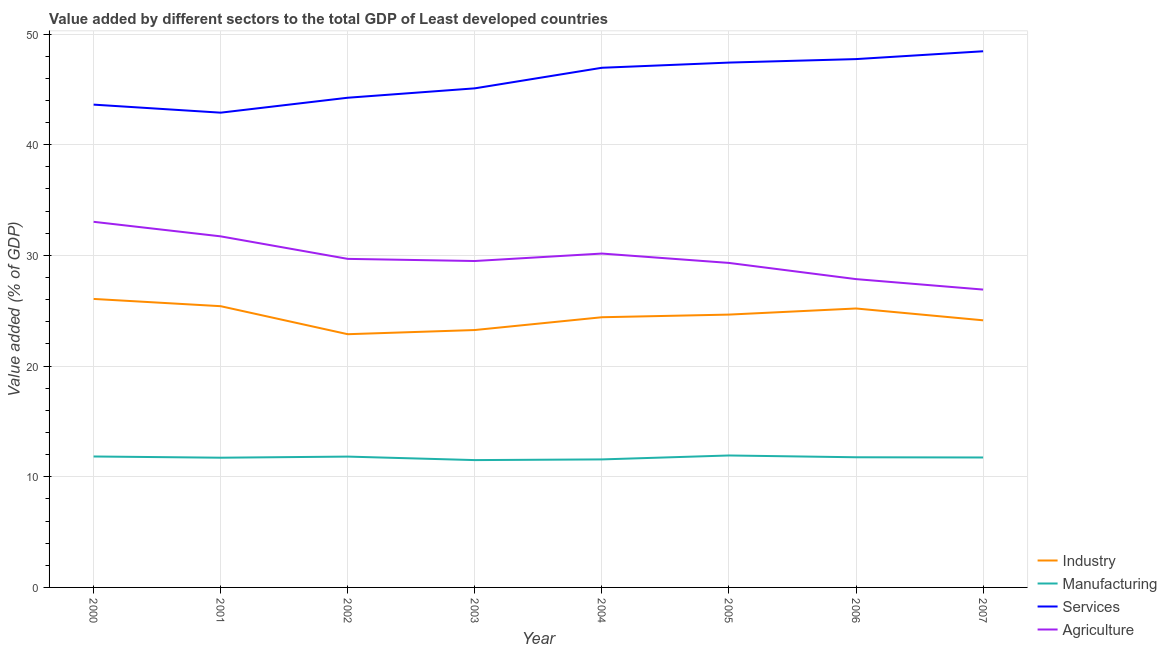Does the line corresponding to value added by services sector intersect with the line corresponding to value added by manufacturing sector?
Offer a very short reply. No. Is the number of lines equal to the number of legend labels?
Offer a very short reply. Yes. What is the value added by services sector in 2001?
Keep it short and to the point. 42.9. Across all years, what is the maximum value added by agricultural sector?
Your answer should be very brief. 33.04. Across all years, what is the minimum value added by services sector?
Offer a terse response. 42.9. In which year was the value added by manufacturing sector maximum?
Offer a very short reply. 2005. What is the total value added by services sector in the graph?
Ensure brevity in your answer.  366.42. What is the difference between the value added by industrial sector in 2001 and that in 2003?
Ensure brevity in your answer.  2.15. What is the difference between the value added by services sector in 2000 and the value added by agricultural sector in 2003?
Keep it short and to the point. 14.13. What is the average value added by services sector per year?
Offer a terse response. 45.8. In the year 2000, what is the difference between the value added by industrial sector and value added by agricultural sector?
Give a very brief answer. -6.97. In how many years, is the value added by agricultural sector greater than 42 %?
Provide a succinct answer. 0. What is the ratio of the value added by industrial sector in 2000 to that in 2006?
Give a very brief answer. 1.03. Is the value added by services sector in 2000 less than that in 2001?
Offer a terse response. No. What is the difference between the highest and the second highest value added by agricultural sector?
Ensure brevity in your answer.  1.31. What is the difference between the highest and the lowest value added by services sector?
Give a very brief answer. 5.55. In how many years, is the value added by services sector greater than the average value added by services sector taken over all years?
Your answer should be compact. 4. Is it the case that in every year, the sum of the value added by manufacturing sector and value added by agricultural sector is greater than the sum of value added by industrial sector and value added by services sector?
Make the answer very short. No. Does the value added by services sector monotonically increase over the years?
Give a very brief answer. No. Does the graph contain grids?
Offer a terse response. Yes. Where does the legend appear in the graph?
Give a very brief answer. Bottom right. What is the title of the graph?
Ensure brevity in your answer.  Value added by different sectors to the total GDP of Least developed countries. Does "CO2 damage" appear as one of the legend labels in the graph?
Keep it short and to the point. No. What is the label or title of the Y-axis?
Your answer should be compact. Value added (% of GDP). What is the Value added (% of GDP) in Industry in 2000?
Give a very brief answer. 26.07. What is the Value added (% of GDP) in Manufacturing in 2000?
Keep it short and to the point. 11.83. What is the Value added (% of GDP) in Services in 2000?
Provide a short and direct response. 43.62. What is the Value added (% of GDP) of Agriculture in 2000?
Your answer should be very brief. 33.04. What is the Value added (% of GDP) in Industry in 2001?
Offer a very short reply. 25.41. What is the Value added (% of GDP) of Manufacturing in 2001?
Offer a very short reply. 11.72. What is the Value added (% of GDP) in Services in 2001?
Offer a very short reply. 42.9. What is the Value added (% of GDP) in Agriculture in 2001?
Provide a short and direct response. 31.72. What is the Value added (% of GDP) in Industry in 2002?
Your answer should be compact. 22.88. What is the Value added (% of GDP) of Manufacturing in 2002?
Offer a very short reply. 11.82. What is the Value added (% of GDP) of Services in 2002?
Provide a short and direct response. 44.25. What is the Value added (% of GDP) of Agriculture in 2002?
Keep it short and to the point. 29.69. What is the Value added (% of GDP) in Industry in 2003?
Keep it short and to the point. 23.26. What is the Value added (% of GDP) of Manufacturing in 2003?
Give a very brief answer. 11.51. What is the Value added (% of GDP) in Services in 2003?
Your answer should be compact. 45.1. What is the Value added (% of GDP) of Agriculture in 2003?
Keep it short and to the point. 29.49. What is the Value added (% of GDP) of Industry in 2004?
Provide a short and direct response. 24.41. What is the Value added (% of GDP) in Manufacturing in 2004?
Provide a succinct answer. 11.57. What is the Value added (% of GDP) of Services in 2004?
Give a very brief answer. 46.95. What is the Value added (% of GDP) in Agriculture in 2004?
Your answer should be very brief. 30.17. What is the Value added (% of GDP) of Industry in 2005?
Make the answer very short. 24.65. What is the Value added (% of GDP) in Manufacturing in 2005?
Ensure brevity in your answer.  11.92. What is the Value added (% of GDP) of Services in 2005?
Your response must be concise. 47.42. What is the Value added (% of GDP) of Agriculture in 2005?
Provide a succinct answer. 29.32. What is the Value added (% of GDP) of Industry in 2006?
Offer a very short reply. 25.2. What is the Value added (% of GDP) of Manufacturing in 2006?
Your answer should be very brief. 11.76. What is the Value added (% of GDP) of Services in 2006?
Make the answer very short. 47.74. What is the Value added (% of GDP) of Agriculture in 2006?
Keep it short and to the point. 27.86. What is the Value added (% of GDP) in Industry in 2007?
Ensure brevity in your answer.  24.14. What is the Value added (% of GDP) in Manufacturing in 2007?
Keep it short and to the point. 11.74. What is the Value added (% of GDP) of Services in 2007?
Make the answer very short. 48.44. What is the Value added (% of GDP) in Agriculture in 2007?
Give a very brief answer. 26.91. Across all years, what is the maximum Value added (% of GDP) in Industry?
Ensure brevity in your answer.  26.07. Across all years, what is the maximum Value added (% of GDP) in Manufacturing?
Provide a short and direct response. 11.92. Across all years, what is the maximum Value added (% of GDP) of Services?
Offer a terse response. 48.44. Across all years, what is the maximum Value added (% of GDP) in Agriculture?
Provide a short and direct response. 33.04. Across all years, what is the minimum Value added (% of GDP) in Industry?
Offer a very short reply. 22.88. Across all years, what is the minimum Value added (% of GDP) of Manufacturing?
Keep it short and to the point. 11.51. Across all years, what is the minimum Value added (% of GDP) in Services?
Your answer should be very brief. 42.9. Across all years, what is the minimum Value added (% of GDP) of Agriculture?
Provide a short and direct response. 26.91. What is the total Value added (% of GDP) in Industry in the graph?
Your answer should be compact. 196.02. What is the total Value added (% of GDP) in Manufacturing in the graph?
Your response must be concise. 93.87. What is the total Value added (% of GDP) of Services in the graph?
Your answer should be very brief. 366.42. What is the total Value added (% of GDP) in Agriculture in the graph?
Your answer should be very brief. 238.19. What is the difference between the Value added (% of GDP) of Industry in 2000 and that in 2001?
Offer a very short reply. 0.66. What is the difference between the Value added (% of GDP) of Manufacturing in 2000 and that in 2001?
Your answer should be compact. 0.11. What is the difference between the Value added (% of GDP) of Services in 2000 and that in 2001?
Offer a terse response. 0.73. What is the difference between the Value added (% of GDP) of Agriculture in 2000 and that in 2001?
Offer a terse response. 1.31. What is the difference between the Value added (% of GDP) of Industry in 2000 and that in 2002?
Provide a succinct answer. 3.19. What is the difference between the Value added (% of GDP) of Manufacturing in 2000 and that in 2002?
Your answer should be very brief. 0.01. What is the difference between the Value added (% of GDP) of Services in 2000 and that in 2002?
Provide a short and direct response. -0.62. What is the difference between the Value added (% of GDP) of Agriculture in 2000 and that in 2002?
Your response must be concise. 3.35. What is the difference between the Value added (% of GDP) of Industry in 2000 and that in 2003?
Offer a terse response. 2.81. What is the difference between the Value added (% of GDP) of Manufacturing in 2000 and that in 2003?
Your answer should be very brief. 0.33. What is the difference between the Value added (% of GDP) of Services in 2000 and that in 2003?
Provide a succinct answer. -1.47. What is the difference between the Value added (% of GDP) in Agriculture in 2000 and that in 2003?
Provide a short and direct response. 3.54. What is the difference between the Value added (% of GDP) of Industry in 2000 and that in 2004?
Offer a terse response. 1.65. What is the difference between the Value added (% of GDP) of Manufacturing in 2000 and that in 2004?
Provide a succinct answer. 0.26. What is the difference between the Value added (% of GDP) in Services in 2000 and that in 2004?
Ensure brevity in your answer.  -3.33. What is the difference between the Value added (% of GDP) in Agriculture in 2000 and that in 2004?
Your response must be concise. 2.87. What is the difference between the Value added (% of GDP) in Industry in 2000 and that in 2005?
Give a very brief answer. 1.42. What is the difference between the Value added (% of GDP) of Manufacturing in 2000 and that in 2005?
Keep it short and to the point. -0.09. What is the difference between the Value added (% of GDP) of Services in 2000 and that in 2005?
Make the answer very short. -3.8. What is the difference between the Value added (% of GDP) in Agriculture in 2000 and that in 2005?
Ensure brevity in your answer.  3.71. What is the difference between the Value added (% of GDP) of Industry in 2000 and that in 2006?
Your answer should be compact. 0.86. What is the difference between the Value added (% of GDP) in Manufacturing in 2000 and that in 2006?
Provide a short and direct response. 0.07. What is the difference between the Value added (% of GDP) of Services in 2000 and that in 2006?
Provide a short and direct response. -4.11. What is the difference between the Value added (% of GDP) of Agriculture in 2000 and that in 2006?
Your answer should be compact. 5.18. What is the difference between the Value added (% of GDP) in Industry in 2000 and that in 2007?
Provide a succinct answer. 1.93. What is the difference between the Value added (% of GDP) in Manufacturing in 2000 and that in 2007?
Offer a terse response. 0.09. What is the difference between the Value added (% of GDP) in Services in 2000 and that in 2007?
Offer a terse response. -4.82. What is the difference between the Value added (% of GDP) of Agriculture in 2000 and that in 2007?
Give a very brief answer. 6.12. What is the difference between the Value added (% of GDP) in Industry in 2001 and that in 2002?
Offer a very short reply. 2.53. What is the difference between the Value added (% of GDP) in Manufacturing in 2001 and that in 2002?
Give a very brief answer. -0.1. What is the difference between the Value added (% of GDP) in Services in 2001 and that in 2002?
Ensure brevity in your answer.  -1.35. What is the difference between the Value added (% of GDP) in Agriculture in 2001 and that in 2002?
Provide a succinct answer. 2.03. What is the difference between the Value added (% of GDP) in Industry in 2001 and that in 2003?
Your answer should be very brief. 2.15. What is the difference between the Value added (% of GDP) of Manufacturing in 2001 and that in 2003?
Provide a succinct answer. 0.22. What is the difference between the Value added (% of GDP) in Services in 2001 and that in 2003?
Give a very brief answer. -2.2. What is the difference between the Value added (% of GDP) in Agriculture in 2001 and that in 2003?
Your answer should be very brief. 2.23. What is the difference between the Value added (% of GDP) of Industry in 2001 and that in 2004?
Your response must be concise. 1. What is the difference between the Value added (% of GDP) of Manufacturing in 2001 and that in 2004?
Offer a terse response. 0.15. What is the difference between the Value added (% of GDP) of Services in 2001 and that in 2004?
Make the answer very short. -4.06. What is the difference between the Value added (% of GDP) of Agriculture in 2001 and that in 2004?
Provide a succinct answer. 1.55. What is the difference between the Value added (% of GDP) in Industry in 2001 and that in 2005?
Provide a short and direct response. 0.76. What is the difference between the Value added (% of GDP) of Manufacturing in 2001 and that in 2005?
Keep it short and to the point. -0.2. What is the difference between the Value added (% of GDP) in Services in 2001 and that in 2005?
Give a very brief answer. -4.53. What is the difference between the Value added (% of GDP) in Agriculture in 2001 and that in 2005?
Your answer should be very brief. 2.4. What is the difference between the Value added (% of GDP) in Industry in 2001 and that in 2006?
Offer a very short reply. 0.21. What is the difference between the Value added (% of GDP) in Manufacturing in 2001 and that in 2006?
Provide a short and direct response. -0.04. What is the difference between the Value added (% of GDP) of Services in 2001 and that in 2006?
Provide a short and direct response. -4.84. What is the difference between the Value added (% of GDP) of Agriculture in 2001 and that in 2006?
Provide a succinct answer. 3.86. What is the difference between the Value added (% of GDP) in Industry in 2001 and that in 2007?
Your answer should be compact. 1.28. What is the difference between the Value added (% of GDP) in Manufacturing in 2001 and that in 2007?
Your answer should be compact. -0.02. What is the difference between the Value added (% of GDP) in Services in 2001 and that in 2007?
Offer a terse response. -5.55. What is the difference between the Value added (% of GDP) of Agriculture in 2001 and that in 2007?
Your response must be concise. 4.81. What is the difference between the Value added (% of GDP) of Industry in 2002 and that in 2003?
Give a very brief answer. -0.38. What is the difference between the Value added (% of GDP) of Manufacturing in 2002 and that in 2003?
Ensure brevity in your answer.  0.32. What is the difference between the Value added (% of GDP) of Services in 2002 and that in 2003?
Your answer should be compact. -0.85. What is the difference between the Value added (% of GDP) in Agriculture in 2002 and that in 2003?
Ensure brevity in your answer.  0.19. What is the difference between the Value added (% of GDP) in Industry in 2002 and that in 2004?
Offer a very short reply. -1.53. What is the difference between the Value added (% of GDP) of Manufacturing in 2002 and that in 2004?
Keep it short and to the point. 0.25. What is the difference between the Value added (% of GDP) in Services in 2002 and that in 2004?
Make the answer very short. -2.71. What is the difference between the Value added (% of GDP) of Agriculture in 2002 and that in 2004?
Your answer should be very brief. -0.48. What is the difference between the Value added (% of GDP) of Industry in 2002 and that in 2005?
Ensure brevity in your answer.  -1.77. What is the difference between the Value added (% of GDP) of Manufacturing in 2002 and that in 2005?
Your answer should be compact. -0.1. What is the difference between the Value added (% of GDP) in Services in 2002 and that in 2005?
Give a very brief answer. -3.18. What is the difference between the Value added (% of GDP) of Agriculture in 2002 and that in 2005?
Make the answer very short. 0.37. What is the difference between the Value added (% of GDP) in Industry in 2002 and that in 2006?
Your response must be concise. -2.32. What is the difference between the Value added (% of GDP) in Manufacturing in 2002 and that in 2006?
Your answer should be compact. 0.06. What is the difference between the Value added (% of GDP) in Services in 2002 and that in 2006?
Keep it short and to the point. -3.49. What is the difference between the Value added (% of GDP) in Agriculture in 2002 and that in 2006?
Provide a succinct answer. 1.83. What is the difference between the Value added (% of GDP) of Industry in 2002 and that in 2007?
Make the answer very short. -1.26. What is the difference between the Value added (% of GDP) of Manufacturing in 2002 and that in 2007?
Offer a very short reply. 0.08. What is the difference between the Value added (% of GDP) in Services in 2002 and that in 2007?
Offer a very short reply. -4.2. What is the difference between the Value added (% of GDP) in Agriculture in 2002 and that in 2007?
Offer a very short reply. 2.77. What is the difference between the Value added (% of GDP) of Industry in 2003 and that in 2004?
Offer a very short reply. -1.16. What is the difference between the Value added (% of GDP) of Manufacturing in 2003 and that in 2004?
Your response must be concise. -0.06. What is the difference between the Value added (% of GDP) in Services in 2003 and that in 2004?
Your response must be concise. -1.86. What is the difference between the Value added (% of GDP) in Agriculture in 2003 and that in 2004?
Offer a very short reply. -0.67. What is the difference between the Value added (% of GDP) of Industry in 2003 and that in 2005?
Provide a short and direct response. -1.39. What is the difference between the Value added (% of GDP) in Manufacturing in 2003 and that in 2005?
Provide a short and direct response. -0.42. What is the difference between the Value added (% of GDP) of Services in 2003 and that in 2005?
Give a very brief answer. -2.33. What is the difference between the Value added (% of GDP) of Agriculture in 2003 and that in 2005?
Provide a succinct answer. 0.17. What is the difference between the Value added (% of GDP) of Industry in 2003 and that in 2006?
Give a very brief answer. -1.95. What is the difference between the Value added (% of GDP) of Manufacturing in 2003 and that in 2006?
Offer a terse response. -0.26. What is the difference between the Value added (% of GDP) in Services in 2003 and that in 2006?
Your answer should be compact. -2.64. What is the difference between the Value added (% of GDP) in Agriculture in 2003 and that in 2006?
Give a very brief answer. 1.64. What is the difference between the Value added (% of GDP) in Industry in 2003 and that in 2007?
Your answer should be compact. -0.88. What is the difference between the Value added (% of GDP) in Manufacturing in 2003 and that in 2007?
Your answer should be compact. -0.24. What is the difference between the Value added (% of GDP) of Services in 2003 and that in 2007?
Make the answer very short. -3.35. What is the difference between the Value added (% of GDP) in Agriculture in 2003 and that in 2007?
Provide a succinct answer. 2.58. What is the difference between the Value added (% of GDP) of Industry in 2004 and that in 2005?
Provide a succinct answer. -0.24. What is the difference between the Value added (% of GDP) of Manufacturing in 2004 and that in 2005?
Your answer should be very brief. -0.36. What is the difference between the Value added (% of GDP) in Services in 2004 and that in 2005?
Your answer should be very brief. -0.47. What is the difference between the Value added (% of GDP) in Agriculture in 2004 and that in 2005?
Give a very brief answer. 0.85. What is the difference between the Value added (% of GDP) in Industry in 2004 and that in 2006?
Your response must be concise. -0.79. What is the difference between the Value added (% of GDP) of Manufacturing in 2004 and that in 2006?
Keep it short and to the point. -0.19. What is the difference between the Value added (% of GDP) in Services in 2004 and that in 2006?
Offer a terse response. -0.78. What is the difference between the Value added (% of GDP) of Agriculture in 2004 and that in 2006?
Your answer should be very brief. 2.31. What is the difference between the Value added (% of GDP) in Industry in 2004 and that in 2007?
Ensure brevity in your answer.  0.28. What is the difference between the Value added (% of GDP) in Manufacturing in 2004 and that in 2007?
Your answer should be very brief. -0.17. What is the difference between the Value added (% of GDP) of Services in 2004 and that in 2007?
Provide a succinct answer. -1.49. What is the difference between the Value added (% of GDP) in Agriculture in 2004 and that in 2007?
Offer a very short reply. 3.25. What is the difference between the Value added (% of GDP) of Industry in 2005 and that in 2006?
Offer a terse response. -0.55. What is the difference between the Value added (% of GDP) in Manufacturing in 2005 and that in 2006?
Your response must be concise. 0.16. What is the difference between the Value added (% of GDP) of Services in 2005 and that in 2006?
Your answer should be very brief. -0.32. What is the difference between the Value added (% of GDP) in Agriculture in 2005 and that in 2006?
Your answer should be compact. 1.46. What is the difference between the Value added (% of GDP) in Industry in 2005 and that in 2007?
Offer a very short reply. 0.52. What is the difference between the Value added (% of GDP) of Manufacturing in 2005 and that in 2007?
Your answer should be compact. 0.18. What is the difference between the Value added (% of GDP) of Services in 2005 and that in 2007?
Make the answer very short. -1.02. What is the difference between the Value added (% of GDP) in Agriculture in 2005 and that in 2007?
Ensure brevity in your answer.  2.41. What is the difference between the Value added (% of GDP) of Industry in 2006 and that in 2007?
Make the answer very short. 1.07. What is the difference between the Value added (% of GDP) of Manufacturing in 2006 and that in 2007?
Give a very brief answer. 0.02. What is the difference between the Value added (% of GDP) of Services in 2006 and that in 2007?
Ensure brevity in your answer.  -0.71. What is the difference between the Value added (% of GDP) of Agriculture in 2006 and that in 2007?
Offer a very short reply. 0.94. What is the difference between the Value added (% of GDP) of Industry in 2000 and the Value added (% of GDP) of Manufacturing in 2001?
Provide a short and direct response. 14.35. What is the difference between the Value added (% of GDP) in Industry in 2000 and the Value added (% of GDP) in Services in 2001?
Your response must be concise. -16.83. What is the difference between the Value added (% of GDP) in Industry in 2000 and the Value added (% of GDP) in Agriculture in 2001?
Ensure brevity in your answer.  -5.65. What is the difference between the Value added (% of GDP) in Manufacturing in 2000 and the Value added (% of GDP) in Services in 2001?
Give a very brief answer. -31.07. What is the difference between the Value added (% of GDP) of Manufacturing in 2000 and the Value added (% of GDP) of Agriculture in 2001?
Make the answer very short. -19.89. What is the difference between the Value added (% of GDP) of Services in 2000 and the Value added (% of GDP) of Agriculture in 2001?
Keep it short and to the point. 11.9. What is the difference between the Value added (% of GDP) of Industry in 2000 and the Value added (% of GDP) of Manufacturing in 2002?
Provide a succinct answer. 14.25. What is the difference between the Value added (% of GDP) in Industry in 2000 and the Value added (% of GDP) in Services in 2002?
Ensure brevity in your answer.  -18.18. What is the difference between the Value added (% of GDP) in Industry in 2000 and the Value added (% of GDP) in Agriculture in 2002?
Keep it short and to the point. -3.62. What is the difference between the Value added (% of GDP) of Manufacturing in 2000 and the Value added (% of GDP) of Services in 2002?
Your answer should be compact. -32.41. What is the difference between the Value added (% of GDP) in Manufacturing in 2000 and the Value added (% of GDP) in Agriculture in 2002?
Give a very brief answer. -17.86. What is the difference between the Value added (% of GDP) in Services in 2000 and the Value added (% of GDP) in Agriculture in 2002?
Your response must be concise. 13.94. What is the difference between the Value added (% of GDP) in Industry in 2000 and the Value added (% of GDP) in Manufacturing in 2003?
Offer a very short reply. 14.56. What is the difference between the Value added (% of GDP) of Industry in 2000 and the Value added (% of GDP) of Services in 2003?
Your answer should be very brief. -19.03. What is the difference between the Value added (% of GDP) of Industry in 2000 and the Value added (% of GDP) of Agriculture in 2003?
Offer a terse response. -3.43. What is the difference between the Value added (% of GDP) of Manufacturing in 2000 and the Value added (% of GDP) of Services in 2003?
Offer a very short reply. -33.26. What is the difference between the Value added (% of GDP) of Manufacturing in 2000 and the Value added (% of GDP) of Agriculture in 2003?
Your response must be concise. -17.66. What is the difference between the Value added (% of GDP) of Services in 2000 and the Value added (% of GDP) of Agriculture in 2003?
Your answer should be compact. 14.13. What is the difference between the Value added (% of GDP) in Industry in 2000 and the Value added (% of GDP) in Services in 2004?
Give a very brief answer. -20.89. What is the difference between the Value added (% of GDP) of Industry in 2000 and the Value added (% of GDP) of Agriculture in 2004?
Provide a short and direct response. -4.1. What is the difference between the Value added (% of GDP) in Manufacturing in 2000 and the Value added (% of GDP) in Services in 2004?
Your answer should be very brief. -35.12. What is the difference between the Value added (% of GDP) in Manufacturing in 2000 and the Value added (% of GDP) in Agriculture in 2004?
Ensure brevity in your answer.  -18.33. What is the difference between the Value added (% of GDP) in Services in 2000 and the Value added (% of GDP) in Agriculture in 2004?
Keep it short and to the point. 13.46. What is the difference between the Value added (% of GDP) in Industry in 2000 and the Value added (% of GDP) in Manufacturing in 2005?
Your response must be concise. 14.14. What is the difference between the Value added (% of GDP) in Industry in 2000 and the Value added (% of GDP) in Services in 2005?
Keep it short and to the point. -21.35. What is the difference between the Value added (% of GDP) of Industry in 2000 and the Value added (% of GDP) of Agriculture in 2005?
Offer a very short reply. -3.25. What is the difference between the Value added (% of GDP) of Manufacturing in 2000 and the Value added (% of GDP) of Services in 2005?
Offer a terse response. -35.59. What is the difference between the Value added (% of GDP) in Manufacturing in 2000 and the Value added (% of GDP) in Agriculture in 2005?
Offer a terse response. -17.49. What is the difference between the Value added (% of GDP) in Services in 2000 and the Value added (% of GDP) in Agriculture in 2005?
Give a very brief answer. 14.3. What is the difference between the Value added (% of GDP) of Industry in 2000 and the Value added (% of GDP) of Manufacturing in 2006?
Keep it short and to the point. 14.31. What is the difference between the Value added (% of GDP) in Industry in 2000 and the Value added (% of GDP) in Services in 2006?
Offer a very short reply. -21.67. What is the difference between the Value added (% of GDP) in Industry in 2000 and the Value added (% of GDP) in Agriculture in 2006?
Your answer should be very brief. -1.79. What is the difference between the Value added (% of GDP) of Manufacturing in 2000 and the Value added (% of GDP) of Services in 2006?
Your answer should be very brief. -35.91. What is the difference between the Value added (% of GDP) of Manufacturing in 2000 and the Value added (% of GDP) of Agriculture in 2006?
Offer a terse response. -16.03. What is the difference between the Value added (% of GDP) of Services in 2000 and the Value added (% of GDP) of Agriculture in 2006?
Keep it short and to the point. 15.77. What is the difference between the Value added (% of GDP) in Industry in 2000 and the Value added (% of GDP) in Manufacturing in 2007?
Provide a succinct answer. 14.33. What is the difference between the Value added (% of GDP) in Industry in 2000 and the Value added (% of GDP) in Services in 2007?
Provide a succinct answer. -22.38. What is the difference between the Value added (% of GDP) of Industry in 2000 and the Value added (% of GDP) of Agriculture in 2007?
Your answer should be very brief. -0.85. What is the difference between the Value added (% of GDP) of Manufacturing in 2000 and the Value added (% of GDP) of Services in 2007?
Give a very brief answer. -36.61. What is the difference between the Value added (% of GDP) of Manufacturing in 2000 and the Value added (% of GDP) of Agriculture in 2007?
Your answer should be very brief. -15.08. What is the difference between the Value added (% of GDP) of Services in 2000 and the Value added (% of GDP) of Agriculture in 2007?
Your answer should be compact. 16.71. What is the difference between the Value added (% of GDP) of Industry in 2001 and the Value added (% of GDP) of Manufacturing in 2002?
Your response must be concise. 13.59. What is the difference between the Value added (% of GDP) of Industry in 2001 and the Value added (% of GDP) of Services in 2002?
Provide a short and direct response. -18.84. What is the difference between the Value added (% of GDP) in Industry in 2001 and the Value added (% of GDP) in Agriculture in 2002?
Provide a short and direct response. -4.28. What is the difference between the Value added (% of GDP) in Manufacturing in 2001 and the Value added (% of GDP) in Services in 2002?
Provide a short and direct response. -32.53. What is the difference between the Value added (% of GDP) of Manufacturing in 2001 and the Value added (% of GDP) of Agriculture in 2002?
Provide a short and direct response. -17.97. What is the difference between the Value added (% of GDP) in Services in 2001 and the Value added (% of GDP) in Agriculture in 2002?
Ensure brevity in your answer.  13.21. What is the difference between the Value added (% of GDP) in Industry in 2001 and the Value added (% of GDP) in Manufacturing in 2003?
Provide a succinct answer. 13.91. What is the difference between the Value added (% of GDP) in Industry in 2001 and the Value added (% of GDP) in Services in 2003?
Offer a terse response. -19.68. What is the difference between the Value added (% of GDP) in Industry in 2001 and the Value added (% of GDP) in Agriculture in 2003?
Your response must be concise. -4.08. What is the difference between the Value added (% of GDP) of Manufacturing in 2001 and the Value added (% of GDP) of Services in 2003?
Provide a succinct answer. -33.37. What is the difference between the Value added (% of GDP) in Manufacturing in 2001 and the Value added (% of GDP) in Agriculture in 2003?
Keep it short and to the point. -17.77. What is the difference between the Value added (% of GDP) of Services in 2001 and the Value added (% of GDP) of Agriculture in 2003?
Offer a terse response. 13.4. What is the difference between the Value added (% of GDP) in Industry in 2001 and the Value added (% of GDP) in Manufacturing in 2004?
Offer a very short reply. 13.84. What is the difference between the Value added (% of GDP) in Industry in 2001 and the Value added (% of GDP) in Services in 2004?
Give a very brief answer. -21.54. What is the difference between the Value added (% of GDP) in Industry in 2001 and the Value added (% of GDP) in Agriculture in 2004?
Keep it short and to the point. -4.75. What is the difference between the Value added (% of GDP) of Manufacturing in 2001 and the Value added (% of GDP) of Services in 2004?
Keep it short and to the point. -35.23. What is the difference between the Value added (% of GDP) in Manufacturing in 2001 and the Value added (% of GDP) in Agriculture in 2004?
Your answer should be very brief. -18.45. What is the difference between the Value added (% of GDP) in Services in 2001 and the Value added (% of GDP) in Agriculture in 2004?
Provide a succinct answer. 12.73. What is the difference between the Value added (% of GDP) in Industry in 2001 and the Value added (% of GDP) in Manufacturing in 2005?
Provide a succinct answer. 13.49. What is the difference between the Value added (% of GDP) of Industry in 2001 and the Value added (% of GDP) of Services in 2005?
Make the answer very short. -22.01. What is the difference between the Value added (% of GDP) of Industry in 2001 and the Value added (% of GDP) of Agriculture in 2005?
Your answer should be very brief. -3.91. What is the difference between the Value added (% of GDP) of Manufacturing in 2001 and the Value added (% of GDP) of Services in 2005?
Offer a terse response. -35.7. What is the difference between the Value added (% of GDP) of Manufacturing in 2001 and the Value added (% of GDP) of Agriculture in 2005?
Provide a short and direct response. -17.6. What is the difference between the Value added (% of GDP) of Services in 2001 and the Value added (% of GDP) of Agriculture in 2005?
Your response must be concise. 13.58. What is the difference between the Value added (% of GDP) in Industry in 2001 and the Value added (% of GDP) in Manufacturing in 2006?
Ensure brevity in your answer.  13.65. What is the difference between the Value added (% of GDP) of Industry in 2001 and the Value added (% of GDP) of Services in 2006?
Provide a succinct answer. -22.33. What is the difference between the Value added (% of GDP) in Industry in 2001 and the Value added (% of GDP) in Agriculture in 2006?
Give a very brief answer. -2.45. What is the difference between the Value added (% of GDP) in Manufacturing in 2001 and the Value added (% of GDP) in Services in 2006?
Keep it short and to the point. -36.02. What is the difference between the Value added (% of GDP) in Manufacturing in 2001 and the Value added (% of GDP) in Agriculture in 2006?
Your answer should be very brief. -16.14. What is the difference between the Value added (% of GDP) of Services in 2001 and the Value added (% of GDP) of Agriculture in 2006?
Ensure brevity in your answer.  15.04. What is the difference between the Value added (% of GDP) of Industry in 2001 and the Value added (% of GDP) of Manufacturing in 2007?
Make the answer very short. 13.67. What is the difference between the Value added (% of GDP) of Industry in 2001 and the Value added (% of GDP) of Services in 2007?
Make the answer very short. -23.03. What is the difference between the Value added (% of GDP) of Industry in 2001 and the Value added (% of GDP) of Agriculture in 2007?
Provide a succinct answer. -1.5. What is the difference between the Value added (% of GDP) of Manufacturing in 2001 and the Value added (% of GDP) of Services in 2007?
Offer a very short reply. -36.72. What is the difference between the Value added (% of GDP) of Manufacturing in 2001 and the Value added (% of GDP) of Agriculture in 2007?
Offer a very short reply. -15.19. What is the difference between the Value added (% of GDP) of Services in 2001 and the Value added (% of GDP) of Agriculture in 2007?
Make the answer very short. 15.98. What is the difference between the Value added (% of GDP) of Industry in 2002 and the Value added (% of GDP) of Manufacturing in 2003?
Provide a succinct answer. 11.37. What is the difference between the Value added (% of GDP) in Industry in 2002 and the Value added (% of GDP) in Services in 2003?
Your response must be concise. -22.22. What is the difference between the Value added (% of GDP) in Industry in 2002 and the Value added (% of GDP) in Agriculture in 2003?
Provide a short and direct response. -6.61. What is the difference between the Value added (% of GDP) of Manufacturing in 2002 and the Value added (% of GDP) of Services in 2003?
Your response must be concise. -33.27. What is the difference between the Value added (% of GDP) of Manufacturing in 2002 and the Value added (% of GDP) of Agriculture in 2003?
Your response must be concise. -17.67. What is the difference between the Value added (% of GDP) in Services in 2002 and the Value added (% of GDP) in Agriculture in 2003?
Offer a terse response. 14.75. What is the difference between the Value added (% of GDP) in Industry in 2002 and the Value added (% of GDP) in Manufacturing in 2004?
Give a very brief answer. 11.31. What is the difference between the Value added (% of GDP) of Industry in 2002 and the Value added (% of GDP) of Services in 2004?
Offer a terse response. -24.07. What is the difference between the Value added (% of GDP) of Industry in 2002 and the Value added (% of GDP) of Agriculture in 2004?
Offer a terse response. -7.29. What is the difference between the Value added (% of GDP) in Manufacturing in 2002 and the Value added (% of GDP) in Services in 2004?
Offer a terse response. -35.13. What is the difference between the Value added (% of GDP) of Manufacturing in 2002 and the Value added (% of GDP) of Agriculture in 2004?
Your answer should be very brief. -18.34. What is the difference between the Value added (% of GDP) in Services in 2002 and the Value added (% of GDP) in Agriculture in 2004?
Give a very brief answer. 14.08. What is the difference between the Value added (% of GDP) in Industry in 2002 and the Value added (% of GDP) in Manufacturing in 2005?
Offer a terse response. 10.96. What is the difference between the Value added (% of GDP) of Industry in 2002 and the Value added (% of GDP) of Services in 2005?
Make the answer very short. -24.54. What is the difference between the Value added (% of GDP) in Industry in 2002 and the Value added (% of GDP) in Agriculture in 2005?
Provide a short and direct response. -6.44. What is the difference between the Value added (% of GDP) of Manufacturing in 2002 and the Value added (% of GDP) of Services in 2005?
Your answer should be compact. -35.6. What is the difference between the Value added (% of GDP) of Manufacturing in 2002 and the Value added (% of GDP) of Agriculture in 2005?
Offer a very short reply. -17.5. What is the difference between the Value added (% of GDP) in Services in 2002 and the Value added (% of GDP) in Agriculture in 2005?
Offer a very short reply. 14.93. What is the difference between the Value added (% of GDP) of Industry in 2002 and the Value added (% of GDP) of Manufacturing in 2006?
Ensure brevity in your answer.  11.12. What is the difference between the Value added (% of GDP) of Industry in 2002 and the Value added (% of GDP) of Services in 2006?
Provide a succinct answer. -24.86. What is the difference between the Value added (% of GDP) of Industry in 2002 and the Value added (% of GDP) of Agriculture in 2006?
Offer a very short reply. -4.98. What is the difference between the Value added (% of GDP) of Manufacturing in 2002 and the Value added (% of GDP) of Services in 2006?
Your answer should be very brief. -35.92. What is the difference between the Value added (% of GDP) of Manufacturing in 2002 and the Value added (% of GDP) of Agriculture in 2006?
Your response must be concise. -16.04. What is the difference between the Value added (% of GDP) in Services in 2002 and the Value added (% of GDP) in Agriculture in 2006?
Give a very brief answer. 16.39. What is the difference between the Value added (% of GDP) in Industry in 2002 and the Value added (% of GDP) in Manufacturing in 2007?
Your answer should be very brief. 11.14. What is the difference between the Value added (% of GDP) in Industry in 2002 and the Value added (% of GDP) in Services in 2007?
Your response must be concise. -25.56. What is the difference between the Value added (% of GDP) of Industry in 2002 and the Value added (% of GDP) of Agriculture in 2007?
Make the answer very short. -4.03. What is the difference between the Value added (% of GDP) of Manufacturing in 2002 and the Value added (% of GDP) of Services in 2007?
Provide a short and direct response. -36.62. What is the difference between the Value added (% of GDP) of Manufacturing in 2002 and the Value added (% of GDP) of Agriculture in 2007?
Your response must be concise. -15.09. What is the difference between the Value added (% of GDP) of Services in 2002 and the Value added (% of GDP) of Agriculture in 2007?
Make the answer very short. 17.33. What is the difference between the Value added (% of GDP) in Industry in 2003 and the Value added (% of GDP) in Manufacturing in 2004?
Provide a succinct answer. 11.69. What is the difference between the Value added (% of GDP) in Industry in 2003 and the Value added (% of GDP) in Services in 2004?
Provide a succinct answer. -23.7. What is the difference between the Value added (% of GDP) in Industry in 2003 and the Value added (% of GDP) in Agriculture in 2004?
Make the answer very short. -6.91. What is the difference between the Value added (% of GDP) in Manufacturing in 2003 and the Value added (% of GDP) in Services in 2004?
Provide a succinct answer. -35.45. What is the difference between the Value added (% of GDP) of Manufacturing in 2003 and the Value added (% of GDP) of Agriculture in 2004?
Your answer should be very brief. -18.66. What is the difference between the Value added (% of GDP) of Services in 2003 and the Value added (% of GDP) of Agriculture in 2004?
Your answer should be compact. 14.93. What is the difference between the Value added (% of GDP) of Industry in 2003 and the Value added (% of GDP) of Manufacturing in 2005?
Give a very brief answer. 11.34. What is the difference between the Value added (% of GDP) in Industry in 2003 and the Value added (% of GDP) in Services in 2005?
Make the answer very short. -24.16. What is the difference between the Value added (% of GDP) of Industry in 2003 and the Value added (% of GDP) of Agriculture in 2005?
Provide a short and direct response. -6.06. What is the difference between the Value added (% of GDP) in Manufacturing in 2003 and the Value added (% of GDP) in Services in 2005?
Your answer should be compact. -35.92. What is the difference between the Value added (% of GDP) of Manufacturing in 2003 and the Value added (% of GDP) of Agriculture in 2005?
Provide a succinct answer. -17.82. What is the difference between the Value added (% of GDP) in Services in 2003 and the Value added (% of GDP) in Agriculture in 2005?
Keep it short and to the point. 15.77. What is the difference between the Value added (% of GDP) of Industry in 2003 and the Value added (% of GDP) of Manufacturing in 2006?
Keep it short and to the point. 11.5. What is the difference between the Value added (% of GDP) of Industry in 2003 and the Value added (% of GDP) of Services in 2006?
Offer a terse response. -24.48. What is the difference between the Value added (% of GDP) in Industry in 2003 and the Value added (% of GDP) in Agriculture in 2006?
Ensure brevity in your answer.  -4.6. What is the difference between the Value added (% of GDP) of Manufacturing in 2003 and the Value added (% of GDP) of Services in 2006?
Provide a short and direct response. -36.23. What is the difference between the Value added (% of GDP) of Manufacturing in 2003 and the Value added (% of GDP) of Agriculture in 2006?
Ensure brevity in your answer.  -16.35. What is the difference between the Value added (% of GDP) of Services in 2003 and the Value added (% of GDP) of Agriculture in 2006?
Your response must be concise. 17.24. What is the difference between the Value added (% of GDP) of Industry in 2003 and the Value added (% of GDP) of Manufacturing in 2007?
Make the answer very short. 11.52. What is the difference between the Value added (% of GDP) of Industry in 2003 and the Value added (% of GDP) of Services in 2007?
Provide a succinct answer. -25.19. What is the difference between the Value added (% of GDP) of Industry in 2003 and the Value added (% of GDP) of Agriculture in 2007?
Offer a terse response. -3.65. What is the difference between the Value added (% of GDP) of Manufacturing in 2003 and the Value added (% of GDP) of Services in 2007?
Offer a very short reply. -36.94. What is the difference between the Value added (% of GDP) in Manufacturing in 2003 and the Value added (% of GDP) in Agriculture in 2007?
Offer a terse response. -15.41. What is the difference between the Value added (% of GDP) of Services in 2003 and the Value added (% of GDP) of Agriculture in 2007?
Make the answer very short. 18.18. What is the difference between the Value added (% of GDP) of Industry in 2004 and the Value added (% of GDP) of Manufacturing in 2005?
Ensure brevity in your answer.  12.49. What is the difference between the Value added (% of GDP) in Industry in 2004 and the Value added (% of GDP) in Services in 2005?
Offer a terse response. -23.01. What is the difference between the Value added (% of GDP) in Industry in 2004 and the Value added (% of GDP) in Agriculture in 2005?
Ensure brevity in your answer.  -4.91. What is the difference between the Value added (% of GDP) of Manufacturing in 2004 and the Value added (% of GDP) of Services in 2005?
Ensure brevity in your answer.  -35.85. What is the difference between the Value added (% of GDP) in Manufacturing in 2004 and the Value added (% of GDP) in Agriculture in 2005?
Give a very brief answer. -17.75. What is the difference between the Value added (% of GDP) in Services in 2004 and the Value added (% of GDP) in Agriculture in 2005?
Provide a short and direct response. 17.63. What is the difference between the Value added (% of GDP) of Industry in 2004 and the Value added (% of GDP) of Manufacturing in 2006?
Your answer should be compact. 12.65. What is the difference between the Value added (% of GDP) in Industry in 2004 and the Value added (% of GDP) in Services in 2006?
Your response must be concise. -23.32. What is the difference between the Value added (% of GDP) in Industry in 2004 and the Value added (% of GDP) in Agriculture in 2006?
Provide a succinct answer. -3.44. What is the difference between the Value added (% of GDP) of Manufacturing in 2004 and the Value added (% of GDP) of Services in 2006?
Provide a succinct answer. -36.17. What is the difference between the Value added (% of GDP) in Manufacturing in 2004 and the Value added (% of GDP) in Agriculture in 2006?
Provide a succinct answer. -16.29. What is the difference between the Value added (% of GDP) in Services in 2004 and the Value added (% of GDP) in Agriculture in 2006?
Make the answer very short. 19.1. What is the difference between the Value added (% of GDP) in Industry in 2004 and the Value added (% of GDP) in Manufacturing in 2007?
Offer a terse response. 12.67. What is the difference between the Value added (% of GDP) in Industry in 2004 and the Value added (% of GDP) in Services in 2007?
Make the answer very short. -24.03. What is the difference between the Value added (% of GDP) of Industry in 2004 and the Value added (% of GDP) of Agriculture in 2007?
Your answer should be compact. -2.5. What is the difference between the Value added (% of GDP) in Manufacturing in 2004 and the Value added (% of GDP) in Services in 2007?
Provide a succinct answer. -36.88. What is the difference between the Value added (% of GDP) of Manufacturing in 2004 and the Value added (% of GDP) of Agriculture in 2007?
Offer a terse response. -15.35. What is the difference between the Value added (% of GDP) in Services in 2004 and the Value added (% of GDP) in Agriculture in 2007?
Offer a terse response. 20.04. What is the difference between the Value added (% of GDP) in Industry in 2005 and the Value added (% of GDP) in Manufacturing in 2006?
Offer a terse response. 12.89. What is the difference between the Value added (% of GDP) of Industry in 2005 and the Value added (% of GDP) of Services in 2006?
Give a very brief answer. -23.09. What is the difference between the Value added (% of GDP) of Industry in 2005 and the Value added (% of GDP) of Agriculture in 2006?
Your answer should be very brief. -3.21. What is the difference between the Value added (% of GDP) of Manufacturing in 2005 and the Value added (% of GDP) of Services in 2006?
Give a very brief answer. -35.82. What is the difference between the Value added (% of GDP) of Manufacturing in 2005 and the Value added (% of GDP) of Agriculture in 2006?
Give a very brief answer. -15.93. What is the difference between the Value added (% of GDP) in Services in 2005 and the Value added (% of GDP) in Agriculture in 2006?
Keep it short and to the point. 19.57. What is the difference between the Value added (% of GDP) in Industry in 2005 and the Value added (% of GDP) in Manufacturing in 2007?
Offer a very short reply. 12.91. What is the difference between the Value added (% of GDP) of Industry in 2005 and the Value added (% of GDP) of Services in 2007?
Give a very brief answer. -23.79. What is the difference between the Value added (% of GDP) of Industry in 2005 and the Value added (% of GDP) of Agriculture in 2007?
Your response must be concise. -2.26. What is the difference between the Value added (% of GDP) of Manufacturing in 2005 and the Value added (% of GDP) of Services in 2007?
Ensure brevity in your answer.  -36.52. What is the difference between the Value added (% of GDP) of Manufacturing in 2005 and the Value added (% of GDP) of Agriculture in 2007?
Make the answer very short. -14.99. What is the difference between the Value added (% of GDP) in Services in 2005 and the Value added (% of GDP) in Agriculture in 2007?
Provide a short and direct response. 20.51. What is the difference between the Value added (% of GDP) of Industry in 2006 and the Value added (% of GDP) of Manufacturing in 2007?
Offer a very short reply. 13.46. What is the difference between the Value added (% of GDP) of Industry in 2006 and the Value added (% of GDP) of Services in 2007?
Your answer should be compact. -23.24. What is the difference between the Value added (% of GDP) in Industry in 2006 and the Value added (% of GDP) in Agriculture in 2007?
Offer a very short reply. -1.71. What is the difference between the Value added (% of GDP) in Manufacturing in 2006 and the Value added (% of GDP) in Services in 2007?
Ensure brevity in your answer.  -36.68. What is the difference between the Value added (% of GDP) in Manufacturing in 2006 and the Value added (% of GDP) in Agriculture in 2007?
Provide a short and direct response. -15.15. What is the difference between the Value added (% of GDP) of Services in 2006 and the Value added (% of GDP) of Agriculture in 2007?
Your response must be concise. 20.83. What is the average Value added (% of GDP) in Industry per year?
Your answer should be very brief. 24.5. What is the average Value added (% of GDP) of Manufacturing per year?
Give a very brief answer. 11.73. What is the average Value added (% of GDP) in Services per year?
Keep it short and to the point. 45.8. What is the average Value added (% of GDP) of Agriculture per year?
Your answer should be compact. 29.77. In the year 2000, what is the difference between the Value added (% of GDP) of Industry and Value added (% of GDP) of Manufacturing?
Keep it short and to the point. 14.24. In the year 2000, what is the difference between the Value added (% of GDP) of Industry and Value added (% of GDP) of Services?
Provide a short and direct response. -17.56. In the year 2000, what is the difference between the Value added (% of GDP) in Industry and Value added (% of GDP) in Agriculture?
Give a very brief answer. -6.97. In the year 2000, what is the difference between the Value added (% of GDP) of Manufacturing and Value added (% of GDP) of Services?
Your response must be concise. -31.79. In the year 2000, what is the difference between the Value added (% of GDP) of Manufacturing and Value added (% of GDP) of Agriculture?
Offer a terse response. -21.2. In the year 2000, what is the difference between the Value added (% of GDP) in Services and Value added (% of GDP) in Agriculture?
Offer a terse response. 10.59. In the year 2001, what is the difference between the Value added (% of GDP) in Industry and Value added (% of GDP) in Manufacturing?
Offer a terse response. 13.69. In the year 2001, what is the difference between the Value added (% of GDP) of Industry and Value added (% of GDP) of Services?
Offer a very short reply. -17.49. In the year 2001, what is the difference between the Value added (% of GDP) in Industry and Value added (% of GDP) in Agriculture?
Your answer should be compact. -6.31. In the year 2001, what is the difference between the Value added (% of GDP) in Manufacturing and Value added (% of GDP) in Services?
Make the answer very short. -31.18. In the year 2001, what is the difference between the Value added (% of GDP) in Manufacturing and Value added (% of GDP) in Agriculture?
Your response must be concise. -20. In the year 2001, what is the difference between the Value added (% of GDP) of Services and Value added (% of GDP) of Agriculture?
Offer a very short reply. 11.18. In the year 2002, what is the difference between the Value added (% of GDP) of Industry and Value added (% of GDP) of Manufacturing?
Provide a short and direct response. 11.06. In the year 2002, what is the difference between the Value added (% of GDP) of Industry and Value added (% of GDP) of Services?
Your answer should be compact. -21.37. In the year 2002, what is the difference between the Value added (% of GDP) in Industry and Value added (% of GDP) in Agriculture?
Your answer should be very brief. -6.81. In the year 2002, what is the difference between the Value added (% of GDP) in Manufacturing and Value added (% of GDP) in Services?
Give a very brief answer. -32.42. In the year 2002, what is the difference between the Value added (% of GDP) of Manufacturing and Value added (% of GDP) of Agriculture?
Provide a succinct answer. -17.86. In the year 2002, what is the difference between the Value added (% of GDP) in Services and Value added (% of GDP) in Agriculture?
Keep it short and to the point. 14.56. In the year 2003, what is the difference between the Value added (% of GDP) of Industry and Value added (% of GDP) of Manufacturing?
Ensure brevity in your answer.  11.75. In the year 2003, what is the difference between the Value added (% of GDP) in Industry and Value added (% of GDP) in Services?
Keep it short and to the point. -21.84. In the year 2003, what is the difference between the Value added (% of GDP) in Industry and Value added (% of GDP) in Agriculture?
Offer a very short reply. -6.24. In the year 2003, what is the difference between the Value added (% of GDP) of Manufacturing and Value added (% of GDP) of Services?
Offer a terse response. -33.59. In the year 2003, what is the difference between the Value added (% of GDP) in Manufacturing and Value added (% of GDP) in Agriculture?
Provide a succinct answer. -17.99. In the year 2003, what is the difference between the Value added (% of GDP) in Services and Value added (% of GDP) in Agriculture?
Give a very brief answer. 15.6. In the year 2004, what is the difference between the Value added (% of GDP) of Industry and Value added (% of GDP) of Manufacturing?
Keep it short and to the point. 12.85. In the year 2004, what is the difference between the Value added (% of GDP) of Industry and Value added (% of GDP) of Services?
Your answer should be very brief. -22.54. In the year 2004, what is the difference between the Value added (% of GDP) of Industry and Value added (% of GDP) of Agriculture?
Your answer should be compact. -5.75. In the year 2004, what is the difference between the Value added (% of GDP) of Manufacturing and Value added (% of GDP) of Services?
Keep it short and to the point. -35.39. In the year 2004, what is the difference between the Value added (% of GDP) in Manufacturing and Value added (% of GDP) in Agriculture?
Offer a terse response. -18.6. In the year 2004, what is the difference between the Value added (% of GDP) in Services and Value added (% of GDP) in Agriculture?
Make the answer very short. 16.79. In the year 2005, what is the difference between the Value added (% of GDP) of Industry and Value added (% of GDP) of Manufacturing?
Your answer should be very brief. 12.73. In the year 2005, what is the difference between the Value added (% of GDP) in Industry and Value added (% of GDP) in Services?
Provide a short and direct response. -22.77. In the year 2005, what is the difference between the Value added (% of GDP) of Industry and Value added (% of GDP) of Agriculture?
Provide a short and direct response. -4.67. In the year 2005, what is the difference between the Value added (% of GDP) in Manufacturing and Value added (% of GDP) in Services?
Offer a terse response. -35.5. In the year 2005, what is the difference between the Value added (% of GDP) in Manufacturing and Value added (% of GDP) in Agriculture?
Make the answer very short. -17.4. In the year 2005, what is the difference between the Value added (% of GDP) in Services and Value added (% of GDP) in Agriculture?
Keep it short and to the point. 18.1. In the year 2006, what is the difference between the Value added (% of GDP) in Industry and Value added (% of GDP) in Manufacturing?
Provide a short and direct response. 13.44. In the year 2006, what is the difference between the Value added (% of GDP) of Industry and Value added (% of GDP) of Services?
Your answer should be compact. -22.53. In the year 2006, what is the difference between the Value added (% of GDP) of Industry and Value added (% of GDP) of Agriculture?
Make the answer very short. -2.65. In the year 2006, what is the difference between the Value added (% of GDP) of Manufacturing and Value added (% of GDP) of Services?
Keep it short and to the point. -35.98. In the year 2006, what is the difference between the Value added (% of GDP) in Manufacturing and Value added (% of GDP) in Agriculture?
Give a very brief answer. -16.1. In the year 2006, what is the difference between the Value added (% of GDP) in Services and Value added (% of GDP) in Agriculture?
Give a very brief answer. 19.88. In the year 2007, what is the difference between the Value added (% of GDP) of Industry and Value added (% of GDP) of Manufacturing?
Provide a succinct answer. 12.39. In the year 2007, what is the difference between the Value added (% of GDP) in Industry and Value added (% of GDP) in Services?
Your response must be concise. -24.31. In the year 2007, what is the difference between the Value added (% of GDP) in Industry and Value added (% of GDP) in Agriculture?
Provide a short and direct response. -2.78. In the year 2007, what is the difference between the Value added (% of GDP) of Manufacturing and Value added (% of GDP) of Services?
Provide a succinct answer. -36.7. In the year 2007, what is the difference between the Value added (% of GDP) in Manufacturing and Value added (% of GDP) in Agriculture?
Make the answer very short. -15.17. In the year 2007, what is the difference between the Value added (% of GDP) in Services and Value added (% of GDP) in Agriculture?
Make the answer very short. 21.53. What is the ratio of the Value added (% of GDP) in Industry in 2000 to that in 2001?
Your answer should be very brief. 1.03. What is the ratio of the Value added (% of GDP) of Manufacturing in 2000 to that in 2001?
Offer a terse response. 1.01. What is the ratio of the Value added (% of GDP) in Services in 2000 to that in 2001?
Your answer should be compact. 1.02. What is the ratio of the Value added (% of GDP) of Agriculture in 2000 to that in 2001?
Provide a succinct answer. 1.04. What is the ratio of the Value added (% of GDP) of Industry in 2000 to that in 2002?
Ensure brevity in your answer.  1.14. What is the ratio of the Value added (% of GDP) of Manufacturing in 2000 to that in 2002?
Your response must be concise. 1. What is the ratio of the Value added (% of GDP) of Services in 2000 to that in 2002?
Offer a terse response. 0.99. What is the ratio of the Value added (% of GDP) in Agriculture in 2000 to that in 2002?
Your response must be concise. 1.11. What is the ratio of the Value added (% of GDP) of Industry in 2000 to that in 2003?
Your answer should be very brief. 1.12. What is the ratio of the Value added (% of GDP) of Manufacturing in 2000 to that in 2003?
Ensure brevity in your answer.  1.03. What is the ratio of the Value added (% of GDP) of Services in 2000 to that in 2003?
Give a very brief answer. 0.97. What is the ratio of the Value added (% of GDP) in Agriculture in 2000 to that in 2003?
Provide a succinct answer. 1.12. What is the ratio of the Value added (% of GDP) of Industry in 2000 to that in 2004?
Ensure brevity in your answer.  1.07. What is the ratio of the Value added (% of GDP) in Manufacturing in 2000 to that in 2004?
Offer a very short reply. 1.02. What is the ratio of the Value added (% of GDP) in Services in 2000 to that in 2004?
Provide a succinct answer. 0.93. What is the ratio of the Value added (% of GDP) in Agriculture in 2000 to that in 2004?
Make the answer very short. 1.1. What is the ratio of the Value added (% of GDP) of Industry in 2000 to that in 2005?
Your answer should be compact. 1.06. What is the ratio of the Value added (% of GDP) in Manufacturing in 2000 to that in 2005?
Your response must be concise. 0.99. What is the ratio of the Value added (% of GDP) in Services in 2000 to that in 2005?
Your answer should be very brief. 0.92. What is the ratio of the Value added (% of GDP) in Agriculture in 2000 to that in 2005?
Your response must be concise. 1.13. What is the ratio of the Value added (% of GDP) of Industry in 2000 to that in 2006?
Make the answer very short. 1.03. What is the ratio of the Value added (% of GDP) of Manufacturing in 2000 to that in 2006?
Your answer should be very brief. 1.01. What is the ratio of the Value added (% of GDP) in Services in 2000 to that in 2006?
Your answer should be compact. 0.91. What is the ratio of the Value added (% of GDP) in Agriculture in 2000 to that in 2006?
Your answer should be compact. 1.19. What is the ratio of the Value added (% of GDP) in Industry in 2000 to that in 2007?
Provide a succinct answer. 1.08. What is the ratio of the Value added (% of GDP) in Manufacturing in 2000 to that in 2007?
Your answer should be very brief. 1.01. What is the ratio of the Value added (% of GDP) of Services in 2000 to that in 2007?
Offer a terse response. 0.9. What is the ratio of the Value added (% of GDP) in Agriculture in 2000 to that in 2007?
Provide a short and direct response. 1.23. What is the ratio of the Value added (% of GDP) in Industry in 2001 to that in 2002?
Offer a terse response. 1.11. What is the ratio of the Value added (% of GDP) in Manufacturing in 2001 to that in 2002?
Make the answer very short. 0.99. What is the ratio of the Value added (% of GDP) in Services in 2001 to that in 2002?
Offer a very short reply. 0.97. What is the ratio of the Value added (% of GDP) of Agriculture in 2001 to that in 2002?
Your response must be concise. 1.07. What is the ratio of the Value added (% of GDP) in Industry in 2001 to that in 2003?
Offer a terse response. 1.09. What is the ratio of the Value added (% of GDP) of Manufacturing in 2001 to that in 2003?
Keep it short and to the point. 1.02. What is the ratio of the Value added (% of GDP) of Services in 2001 to that in 2003?
Ensure brevity in your answer.  0.95. What is the ratio of the Value added (% of GDP) in Agriculture in 2001 to that in 2003?
Your answer should be very brief. 1.08. What is the ratio of the Value added (% of GDP) of Industry in 2001 to that in 2004?
Keep it short and to the point. 1.04. What is the ratio of the Value added (% of GDP) in Manufacturing in 2001 to that in 2004?
Your response must be concise. 1.01. What is the ratio of the Value added (% of GDP) of Services in 2001 to that in 2004?
Provide a succinct answer. 0.91. What is the ratio of the Value added (% of GDP) in Agriculture in 2001 to that in 2004?
Ensure brevity in your answer.  1.05. What is the ratio of the Value added (% of GDP) of Industry in 2001 to that in 2005?
Provide a short and direct response. 1.03. What is the ratio of the Value added (% of GDP) in Manufacturing in 2001 to that in 2005?
Keep it short and to the point. 0.98. What is the ratio of the Value added (% of GDP) of Services in 2001 to that in 2005?
Your answer should be very brief. 0.9. What is the ratio of the Value added (% of GDP) in Agriculture in 2001 to that in 2005?
Make the answer very short. 1.08. What is the ratio of the Value added (% of GDP) in Industry in 2001 to that in 2006?
Give a very brief answer. 1.01. What is the ratio of the Value added (% of GDP) in Manufacturing in 2001 to that in 2006?
Provide a succinct answer. 1. What is the ratio of the Value added (% of GDP) of Services in 2001 to that in 2006?
Ensure brevity in your answer.  0.9. What is the ratio of the Value added (% of GDP) of Agriculture in 2001 to that in 2006?
Offer a terse response. 1.14. What is the ratio of the Value added (% of GDP) of Industry in 2001 to that in 2007?
Give a very brief answer. 1.05. What is the ratio of the Value added (% of GDP) of Manufacturing in 2001 to that in 2007?
Offer a terse response. 1. What is the ratio of the Value added (% of GDP) of Services in 2001 to that in 2007?
Offer a very short reply. 0.89. What is the ratio of the Value added (% of GDP) in Agriculture in 2001 to that in 2007?
Provide a succinct answer. 1.18. What is the ratio of the Value added (% of GDP) of Industry in 2002 to that in 2003?
Ensure brevity in your answer.  0.98. What is the ratio of the Value added (% of GDP) of Manufacturing in 2002 to that in 2003?
Ensure brevity in your answer.  1.03. What is the ratio of the Value added (% of GDP) in Services in 2002 to that in 2003?
Provide a short and direct response. 0.98. What is the ratio of the Value added (% of GDP) of Industry in 2002 to that in 2004?
Ensure brevity in your answer.  0.94. What is the ratio of the Value added (% of GDP) of Manufacturing in 2002 to that in 2004?
Keep it short and to the point. 1.02. What is the ratio of the Value added (% of GDP) in Services in 2002 to that in 2004?
Ensure brevity in your answer.  0.94. What is the ratio of the Value added (% of GDP) of Agriculture in 2002 to that in 2004?
Make the answer very short. 0.98. What is the ratio of the Value added (% of GDP) in Industry in 2002 to that in 2005?
Keep it short and to the point. 0.93. What is the ratio of the Value added (% of GDP) in Manufacturing in 2002 to that in 2005?
Offer a terse response. 0.99. What is the ratio of the Value added (% of GDP) of Services in 2002 to that in 2005?
Make the answer very short. 0.93. What is the ratio of the Value added (% of GDP) in Agriculture in 2002 to that in 2005?
Give a very brief answer. 1.01. What is the ratio of the Value added (% of GDP) in Industry in 2002 to that in 2006?
Your answer should be very brief. 0.91. What is the ratio of the Value added (% of GDP) in Manufacturing in 2002 to that in 2006?
Your answer should be very brief. 1.01. What is the ratio of the Value added (% of GDP) of Services in 2002 to that in 2006?
Your answer should be very brief. 0.93. What is the ratio of the Value added (% of GDP) of Agriculture in 2002 to that in 2006?
Provide a succinct answer. 1.07. What is the ratio of the Value added (% of GDP) of Industry in 2002 to that in 2007?
Keep it short and to the point. 0.95. What is the ratio of the Value added (% of GDP) in Services in 2002 to that in 2007?
Your response must be concise. 0.91. What is the ratio of the Value added (% of GDP) of Agriculture in 2002 to that in 2007?
Keep it short and to the point. 1.1. What is the ratio of the Value added (% of GDP) in Industry in 2003 to that in 2004?
Keep it short and to the point. 0.95. What is the ratio of the Value added (% of GDP) of Services in 2003 to that in 2004?
Provide a short and direct response. 0.96. What is the ratio of the Value added (% of GDP) in Agriculture in 2003 to that in 2004?
Your answer should be compact. 0.98. What is the ratio of the Value added (% of GDP) of Industry in 2003 to that in 2005?
Provide a succinct answer. 0.94. What is the ratio of the Value added (% of GDP) of Manufacturing in 2003 to that in 2005?
Keep it short and to the point. 0.96. What is the ratio of the Value added (% of GDP) of Services in 2003 to that in 2005?
Offer a very short reply. 0.95. What is the ratio of the Value added (% of GDP) of Agriculture in 2003 to that in 2005?
Provide a short and direct response. 1.01. What is the ratio of the Value added (% of GDP) in Industry in 2003 to that in 2006?
Provide a short and direct response. 0.92. What is the ratio of the Value added (% of GDP) of Manufacturing in 2003 to that in 2006?
Offer a terse response. 0.98. What is the ratio of the Value added (% of GDP) of Services in 2003 to that in 2006?
Your response must be concise. 0.94. What is the ratio of the Value added (% of GDP) of Agriculture in 2003 to that in 2006?
Offer a very short reply. 1.06. What is the ratio of the Value added (% of GDP) of Industry in 2003 to that in 2007?
Provide a short and direct response. 0.96. What is the ratio of the Value added (% of GDP) of Services in 2003 to that in 2007?
Provide a succinct answer. 0.93. What is the ratio of the Value added (% of GDP) in Agriculture in 2003 to that in 2007?
Give a very brief answer. 1.1. What is the ratio of the Value added (% of GDP) in Industry in 2004 to that in 2005?
Offer a terse response. 0.99. What is the ratio of the Value added (% of GDP) in Manufacturing in 2004 to that in 2005?
Provide a short and direct response. 0.97. What is the ratio of the Value added (% of GDP) of Services in 2004 to that in 2005?
Ensure brevity in your answer.  0.99. What is the ratio of the Value added (% of GDP) of Agriculture in 2004 to that in 2005?
Your response must be concise. 1.03. What is the ratio of the Value added (% of GDP) of Industry in 2004 to that in 2006?
Your answer should be very brief. 0.97. What is the ratio of the Value added (% of GDP) of Manufacturing in 2004 to that in 2006?
Offer a terse response. 0.98. What is the ratio of the Value added (% of GDP) in Services in 2004 to that in 2006?
Provide a succinct answer. 0.98. What is the ratio of the Value added (% of GDP) of Agriculture in 2004 to that in 2006?
Your response must be concise. 1.08. What is the ratio of the Value added (% of GDP) of Industry in 2004 to that in 2007?
Make the answer very short. 1.01. What is the ratio of the Value added (% of GDP) of Manufacturing in 2004 to that in 2007?
Your response must be concise. 0.99. What is the ratio of the Value added (% of GDP) of Services in 2004 to that in 2007?
Ensure brevity in your answer.  0.97. What is the ratio of the Value added (% of GDP) of Agriculture in 2004 to that in 2007?
Offer a terse response. 1.12. What is the ratio of the Value added (% of GDP) in Industry in 2005 to that in 2006?
Ensure brevity in your answer.  0.98. What is the ratio of the Value added (% of GDP) of Manufacturing in 2005 to that in 2006?
Your answer should be compact. 1.01. What is the ratio of the Value added (% of GDP) of Agriculture in 2005 to that in 2006?
Provide a succinct answer. 1.05. What is the ratio of the Value added (% of GDP) of Industry in 2005 to that in 2007?
Your response must be concise. 1.02. What is the ratio of the Value added (% of GDP) in Manufacturing in 2005 to that in 2007?
Make the answer very short. 1.02. What is the ratio of the Value added (% of GDP) in Services in 2005 to that in 2007?
Offer a very short reply. 0.98. What is the ratio of the Value added (% of GDP) in Agriculture in 2005 to that in 2007?
Provide a succinct answer. 1.09. What is the ratio of the Value added (% of GDP) of Industry in 2006 to that in 2007?
Provide a succinct answer. 1.04. What is the ratio of the Value added (% of GDP) in Services in 2006 to that in 2007?
Your response must be concise. 0.99. What is the ratio of the Value added (% of GDP) in Agriculture in 2006 to that in 2007?
Give a very brief answer. 1.04. What is the difference between the highest and the second highest Value added (% of GDP) of Industry?
Give a very brief answer. 0.66. What is the difference between the highest and the second highest Value added (% of GDP) in Manufacturing?
Ensure brevity in your answer.  0.09. What is the difference between the highest and the second highest Value added (% of GDP) of Services?
Your answer should be very brief. 0.71. What is the difference between the highest and the second highest Value added (% of GDP) of Agriculture?
Your response must be concise. 1.31. What is the difference between the highest and the lowest Value added (% of GDP) in Industry?
Offer a very short reply. 3.19. What is the difference between the highest and the lowest Value added (% of GDP) of Manufacturing?
Your answer should be compact. 0.42. What is the difference between the highest and the lowest Value added (% of GDP) of Services?
Offer a very short reply. 5.55. What is the difference between the highest and the lowest Value added (% of GDP) in Agriculture?
Give a very brief answer. 6.12. 